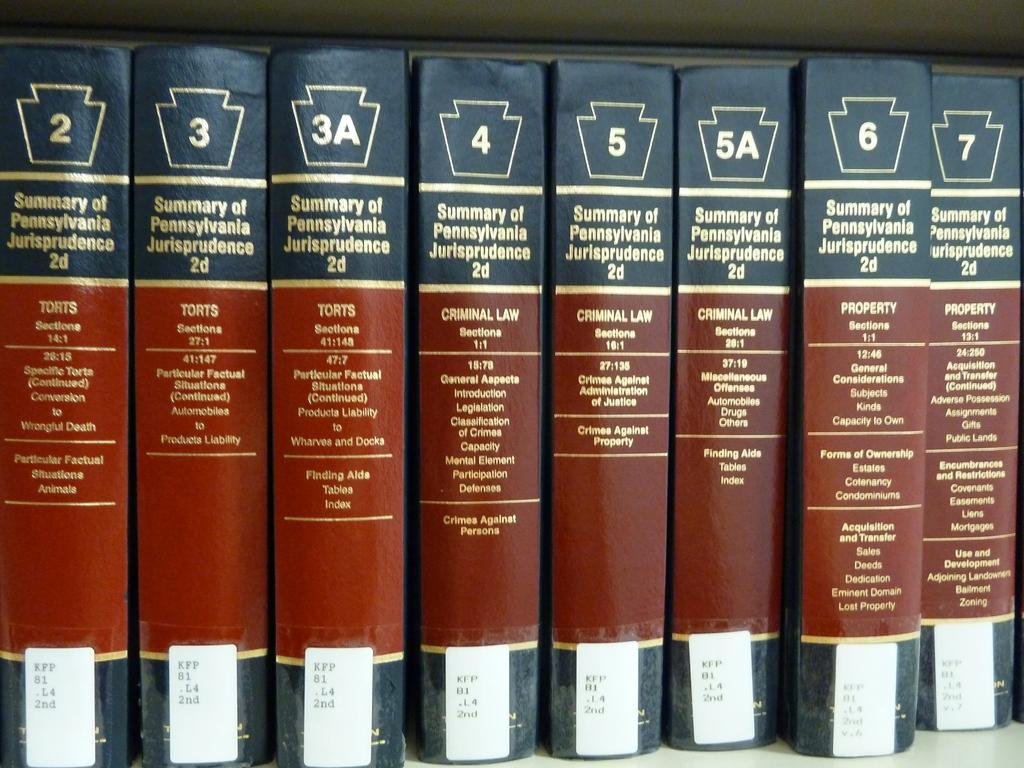<image>
Render a clear and concise summary of the photo. Eight books based on the Summary of Pennsylvania Jurisprudence. 